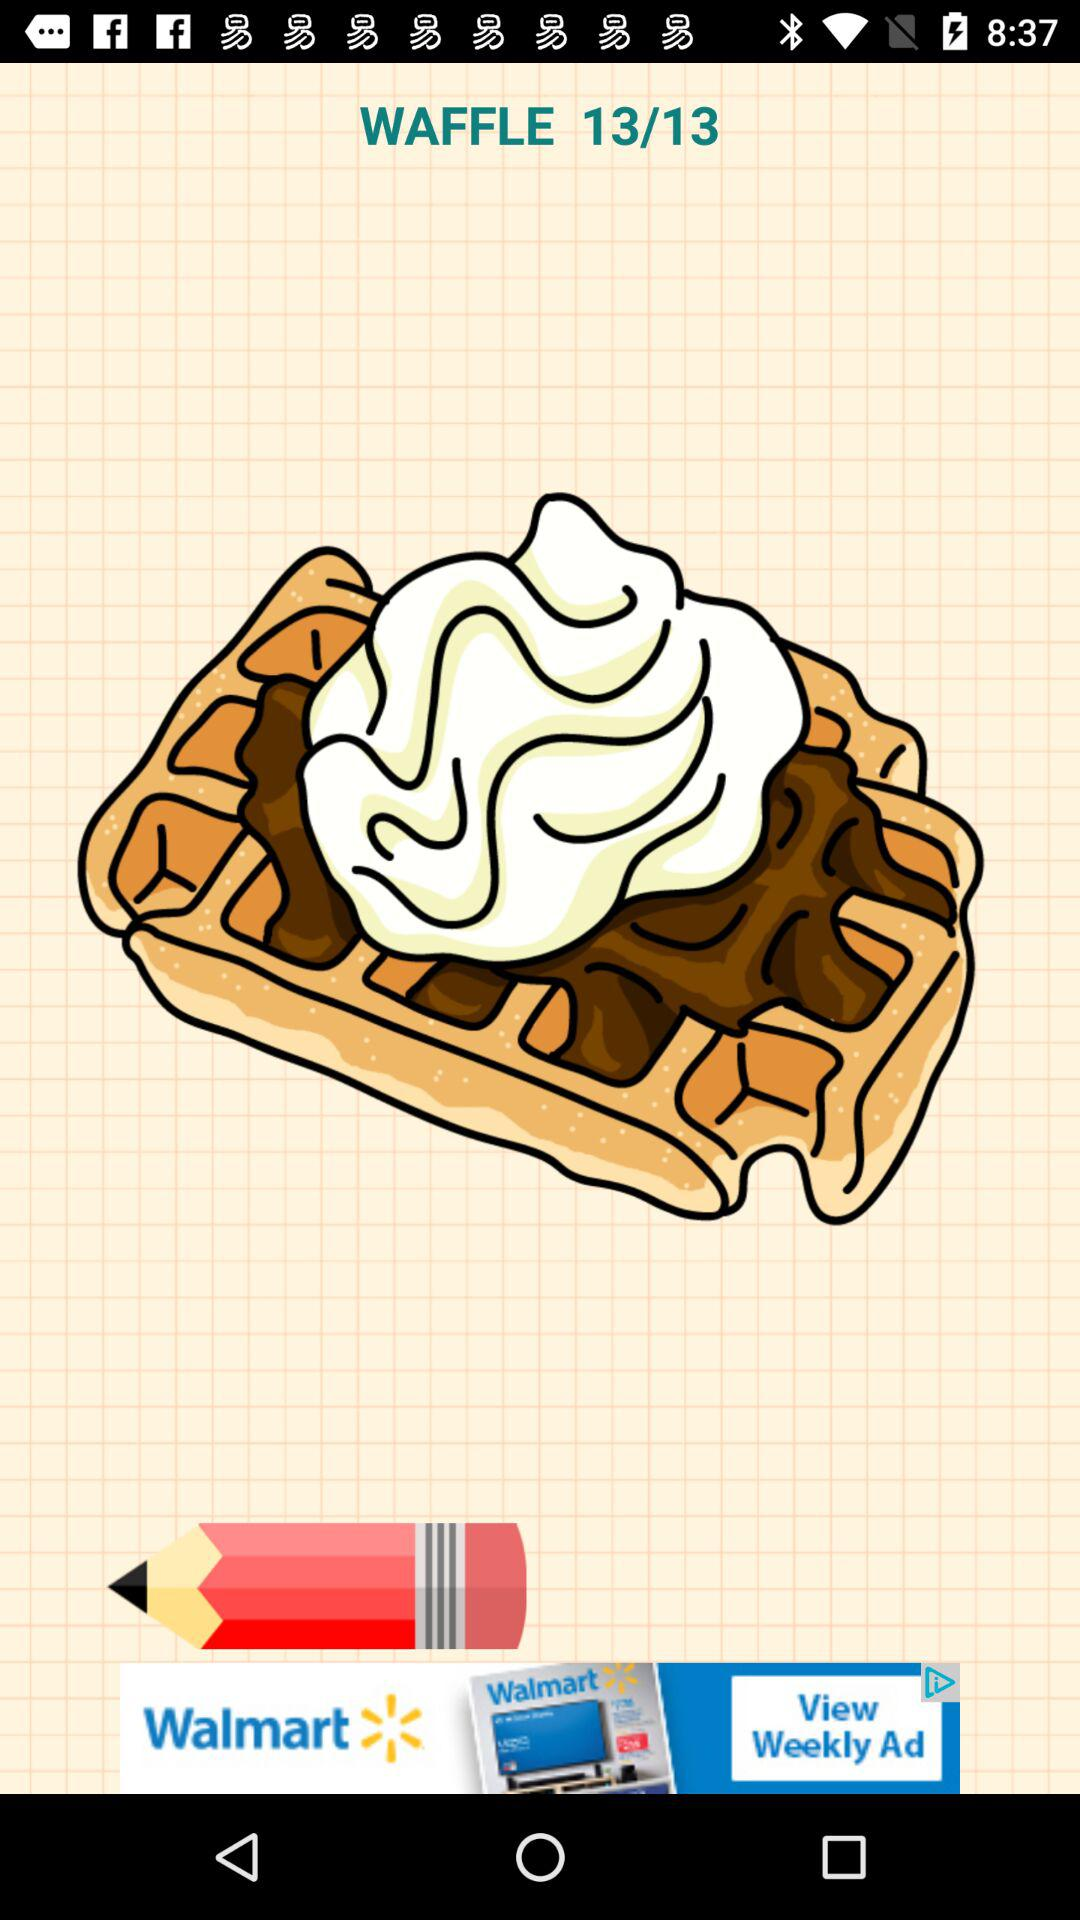What is the name of the dish? The name of the dish is waffle. 